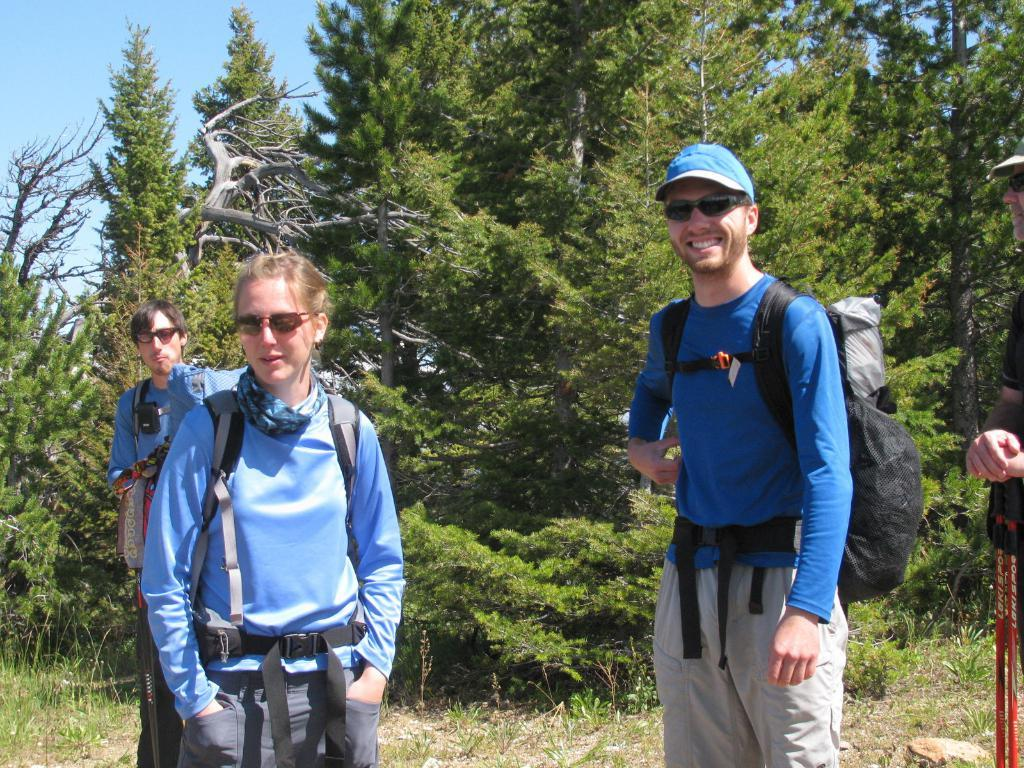What are the people in the image doing? There are people standing on the surface in the image. Can you describe the expressions or actions of the people? One person is smiling, and another person is holding objects. What can be seen in the background of the image? There are trees and the sky visible in the background of the image. What type of stocking is being used to sponge the burn in the image? There is no burn, stocking, or sponge present in the image. 